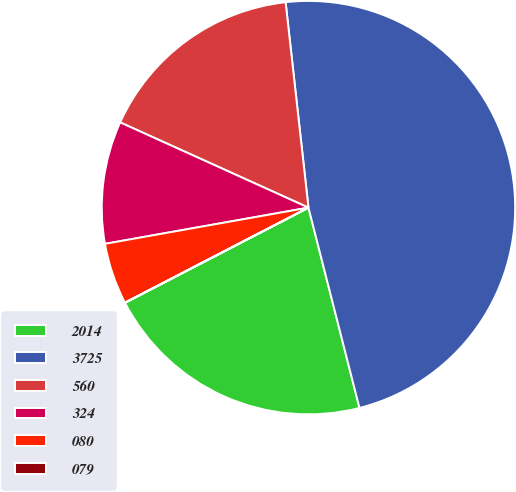Convert chart to OTSL. <chart><loc_0><loc_0><loc_500><loc_500><pie_chart><fcel>2014<fcel>3725<fcel>560<fcel>324<fcel>080<fcel>079<nl><fcel>21.35%<fcel>47.8%<fcel>16.47%<fcel>9.57%<fcel>4.8%<fcel>0.02%<nl></chart> 